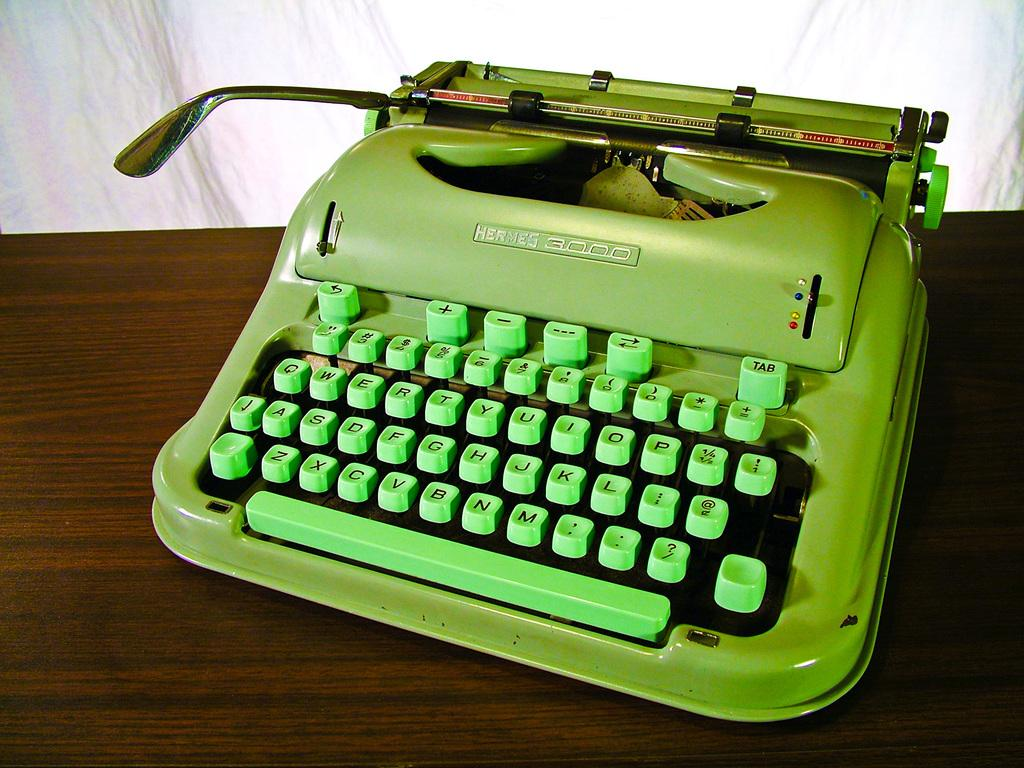<image>
Describe the image concisely. Lime green typewriter that says Hermes on it. 